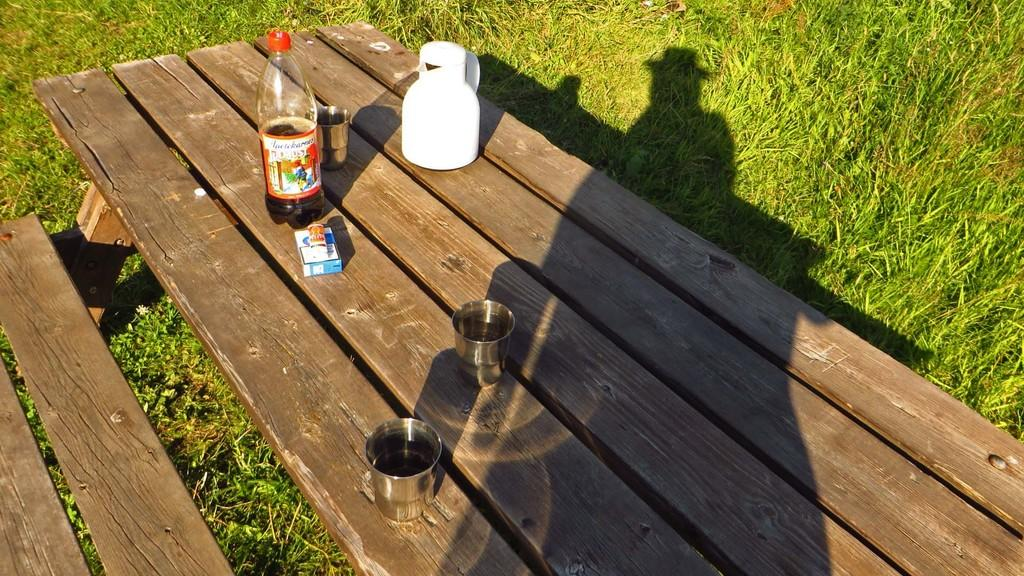What type of container is visible in the image? There is a drink bottle in the image. What other objects can be seen in the image? There is a glass, a jug, and a box in the image. Where are these objects located? The objects are on a wooden table. What can be seen in the background of the image? There is grass visible in the background of the image. What type of ink is being used to write on the ball in the image? There is no ball or ink present in the image. Is there a camera visible in the image? There is no camera present in the image. 